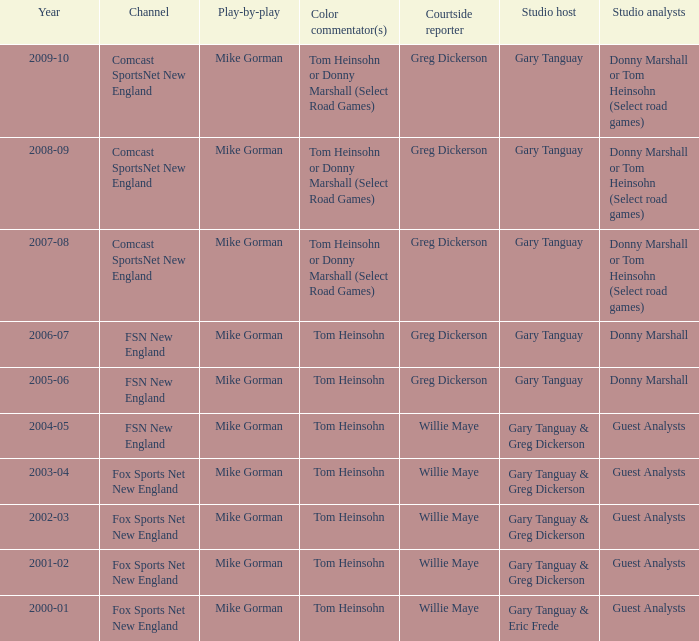In 2009-10, which studio analysts worked with studio host gary tanguay? Donny Marshall or Tom Heinsohn (Select road games). 